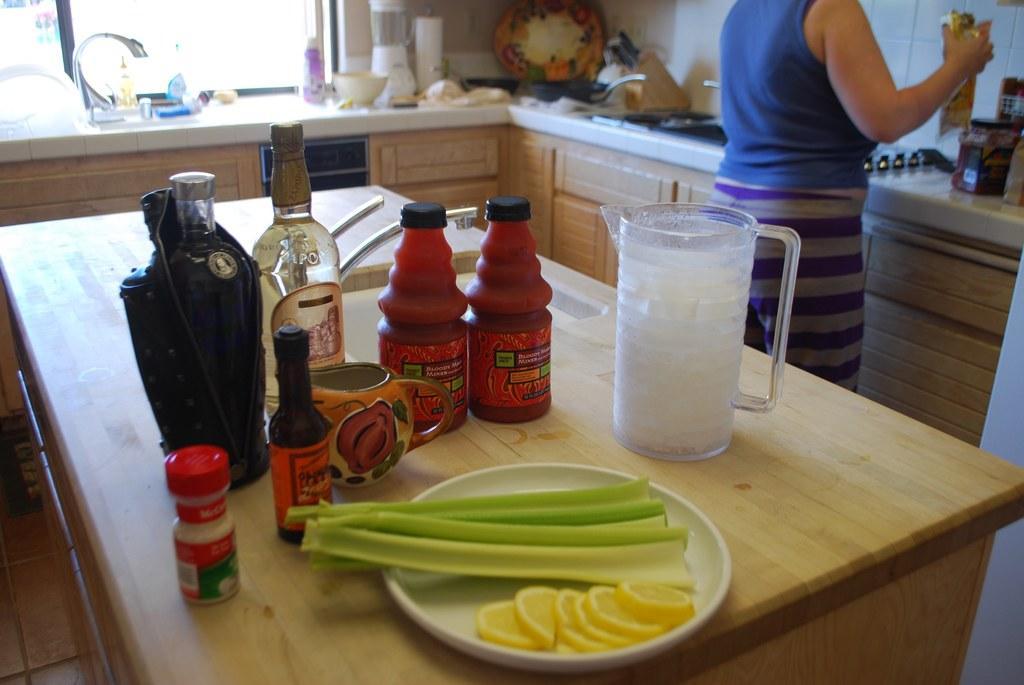Can you describe this image briefly? In the center there is a table,on table we can see wine bottle,cup,sauce bottle,mug,plate and lemon. In the background there is a wall,window,mixer,grinder,plate,sink,tap and one person standing. 